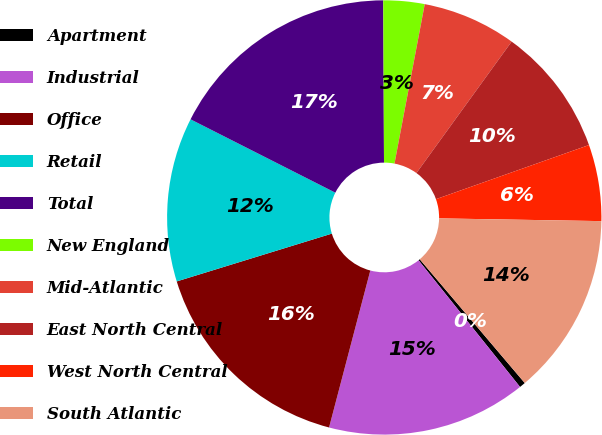<chart> <loc_0><loc_0><loc_500><loc_500><pie_chart><fcel>Apartment<fcel>Industrial<fcel>Office<fcel>Retail<fcel>Total<fcel>New England<fcel>Mid-Atlantic<fcel>East North Central<fcel>West North Central<fcel>South Atlantic<nl><fcel>0.45%<fcel>14.84%<fcel>16.15%<fcel>12.22%<fcel>17.46%<fcel>3.06%<fcel>6.99%<fcel>9.61%<fcel>5.68%<fcel>13.53%<nl></chart> 